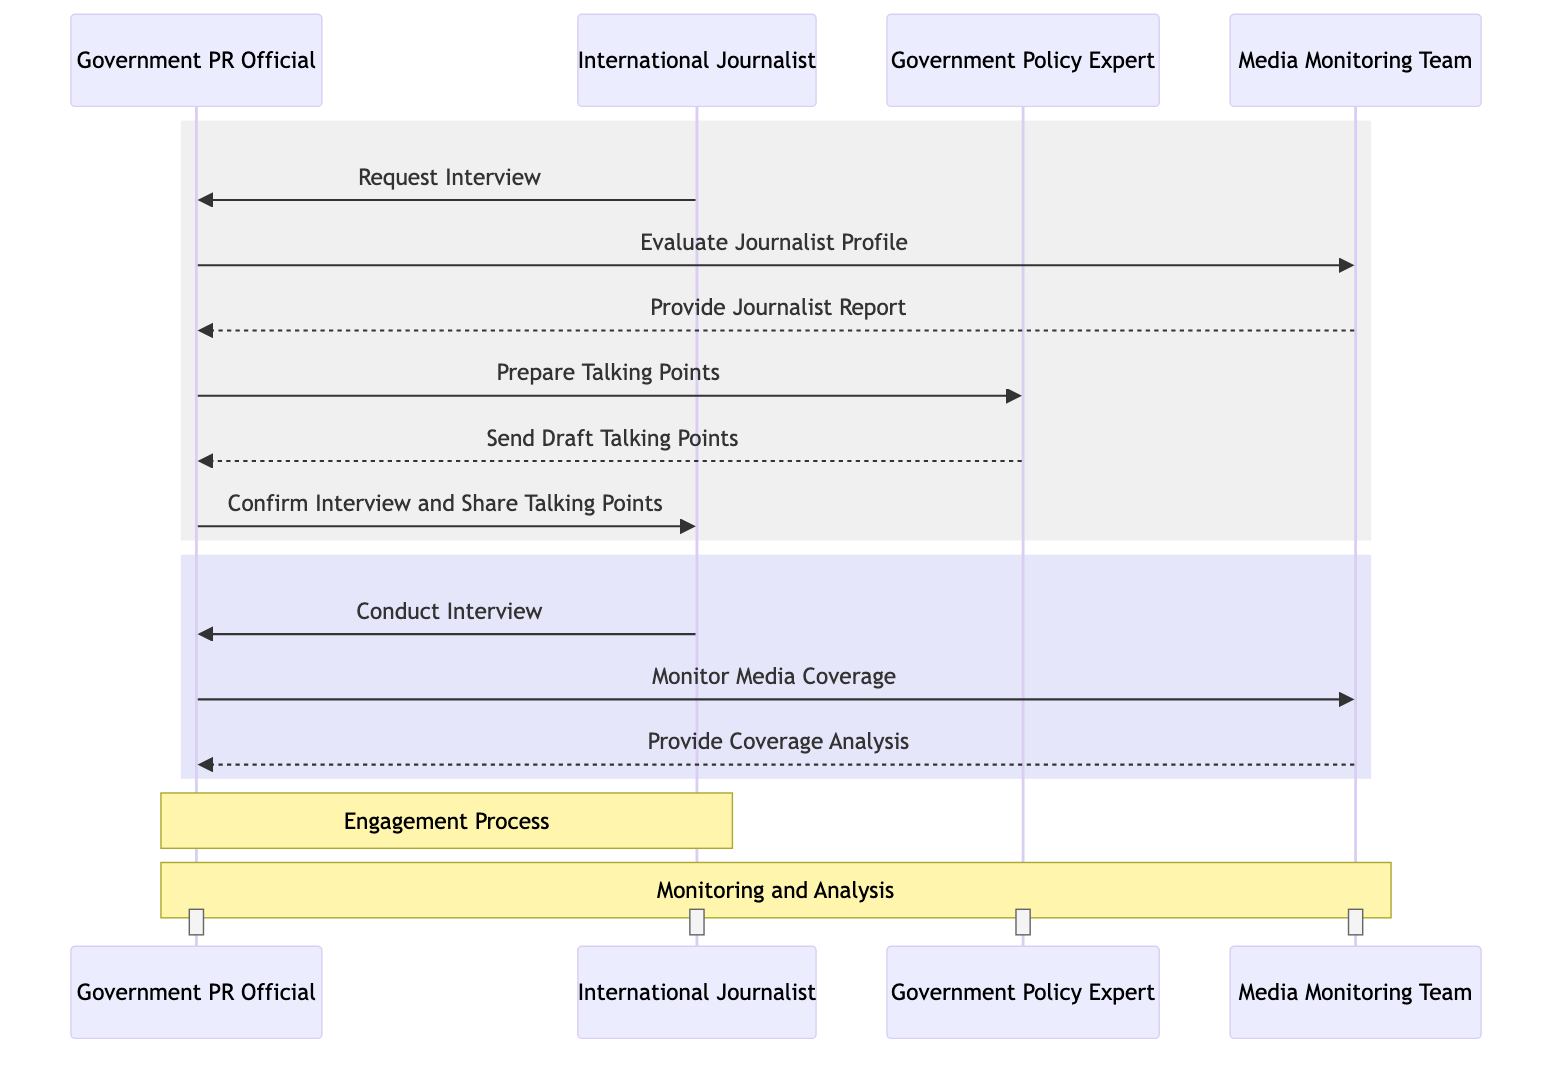What does the International Journalist request from the Government PR Official? The diagram indicates that the International Journalist initiates the process by sending a "Request Interview" message to the Government PR Official.
Answer: Request Interview How many actors are involved in the sequence diagram? The diagram includes four actors: Government PR Official, International Journalist, Government Policy Expert, and Media Monitoring Team, totaling four actors.
Answer: Four Which actor evaluates the Journalist Profile? According to the flow of messages in the diagram, the Government PR Official sends a request to the Media Monitoring Team to "Evaluate Journalist Profile", making the Media Monitoring Team the actor responsible for this action.
Answer: Media Monitoring Team What is sent after the Government Policy Expert prepares the talking points? The Government Policy Expert responds to the Government PR Official by sending "Draft Talking Points". This indicates the direct action following the preparation of the talking points.
Answer: Send Draft Talking Points What is the first action taken by the Government PR Official in response to the International Journalist? After receiving the interview request, the first action taken by the Government PR Official is to instruct the Media Monitoring Team to evaluate the journalist's profile, which is a critical step in the engagement process.
Answer: Evaluate Journalist Profile How many messages are exchanged between the Government PR Official and the International Journalist? The diagram shows two messages exchanged between these actors: the initial "Request Interview" from the International Journalist and the subsequent confirmation "Confirm Interview and Share Talking Points" from the Government PR Official.
Answer: Two What does the Media Monitoring Team provide after evaluating the Journalist Profile? Following the evaluation of the journalist's profile, the Media Monitoring Team provides a report titled "Provide Journalist Report" to the Government PR Official, which is crucial for decision-making.
Answer: Provide Journalist Report What do the Government PR Official and the Media Monitoring Team do after the interview is conducted? Once the interview is conducted, the Government PR Official instructs the Media Monitoring Team to "Monitor Media Coverage", which is a necessary step in evaluating the interview's impact.
Answer: Monitor Media Coverage 